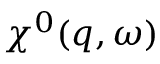<formula> <loc_0><loc_0><loc_500><loc_500>\chi ^ { 0 } ( q , \omega )</formula> 